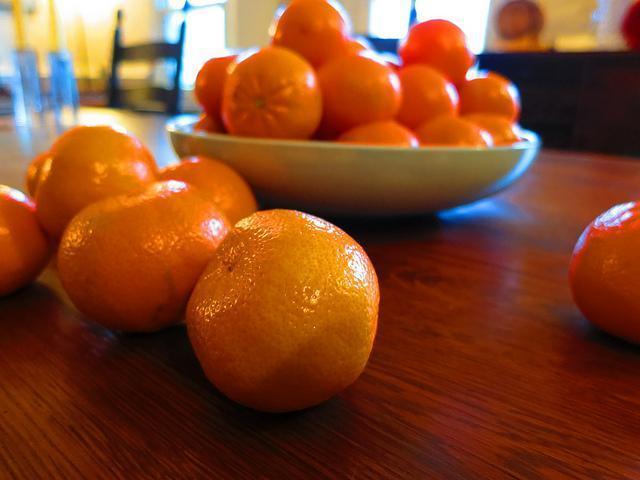How many of the tangerines are not in the bowl?
Give a very brief answer. 6. How many oranges are there?
Give a very brief answer. 7. 